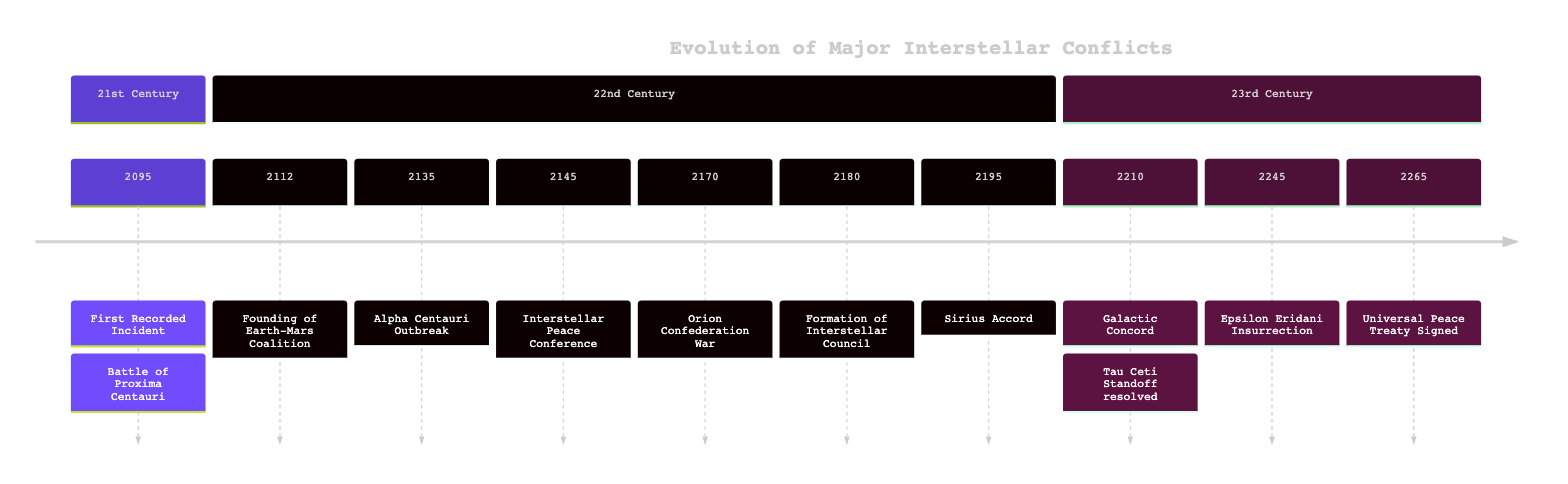What was the first recorded incident in interstellar conflict? The timeline identifies the first recorded incident as the "Battle of Proxima Centauri" in the year 2095. This information is found in the first entry of the timeline.
Answer: Battle of Proxima Centauri What year did the Earth-Mars Coalition get founded? According to the timeline, the founding of the Earth-Mars Coalition occurred in the year 2112. This is the second entry of the timeline.
Answer: 2112 How many major interstellar conflicts are indicated in the timeline? The timeline lists a total of 11 events, comprising various conflicts, treaties, and formations, from the year 2095 to 2265. To determine the number, count each entry.
Answer: 11 Which event involved the signing of a peace treaty following the Tau Ceti Standoff? The timeline mentions the "Galactic Concord," which is specifically noted as a peace agreement after the Tau Ceti Standoff, occurring in 2210. This information is clearly stated in the entry.
Answer: Galactic Concord What significant uprising occurred in 2245? In the year 2245, the timeline records "The Epsilon Eridani Insurrection" as the significant uprising. This is found in the eighth entry of the timeline.
Answer: The Epsilon Eridani Insurrection What was established by the Sirius Accord in 2195? The Sirius Accord, signed in 2195, established demilitarized zones and promoted economic cooperation as indicated in the event description. This involves understanding the nature of the treaty from the corresponding timeline entry.
Answer: Demilitarized zones What organization was formed in 2180 to address interstellar disputes? The timeline states that the "Interstellar Council" was formed in the year 2180. This entry is directly cited in the events listed.
Answer: Interstellar Council Which conflict lasted for five years? The "Orion Confederation War" is noted in the timeline for lasting five years, which is explicitly mentioned in its description. Therefore, it requires checking the entry for its duration.
Answer: Orion Confederation War List the years in which peace treaties were signed. The timeline shows that peace treaties were signed in 2112 (Earth-Mars Coalition), 2195 (Sirius Accord), 2210 (Galactic Concord), and 2265 (Universal Peace Treaty). Thus, providing an enumeration based on these specific entries is necessary.
Answer: 2112, 2195, 2210, 2265 